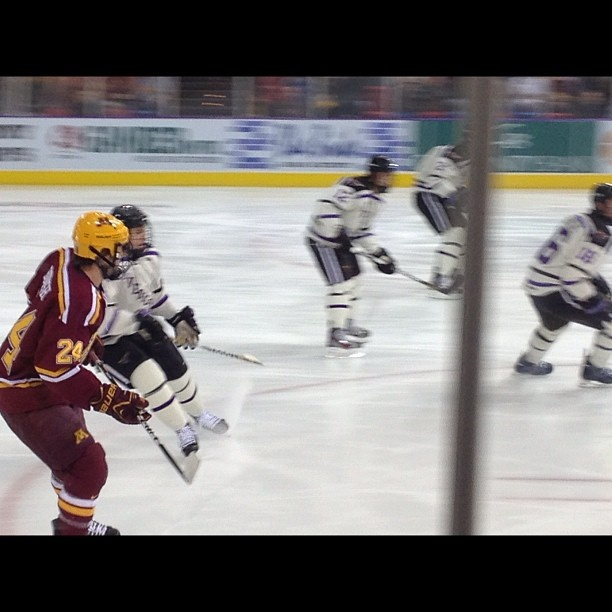Describe the objects in this image and their specific colors. I can see people in black, maroon, gray, and lightgray tones, people in black, darkgray, lightgray, and gray tones, people in black, darkgray, gray, and lightgray tones, people in black, darkgray, gray, and lightgray tones, and people in black, gray, and darkgray tones in this image. 